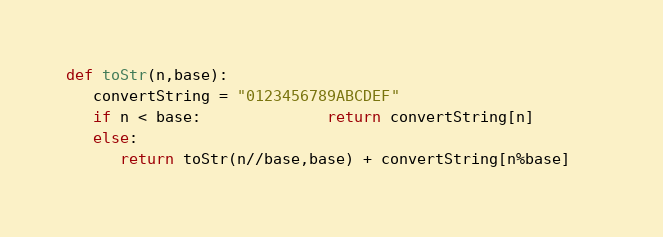Convert code to text. <code><loc_0><loc_0><loc_500><loc_500><_Python_>
def toStr(n,base):
   convertString = "0123456789ABCDEF"
   if n < base:              return convertString[n]
   else:
      return toStr(n//base,base) + convertString[n%base]   </code> 